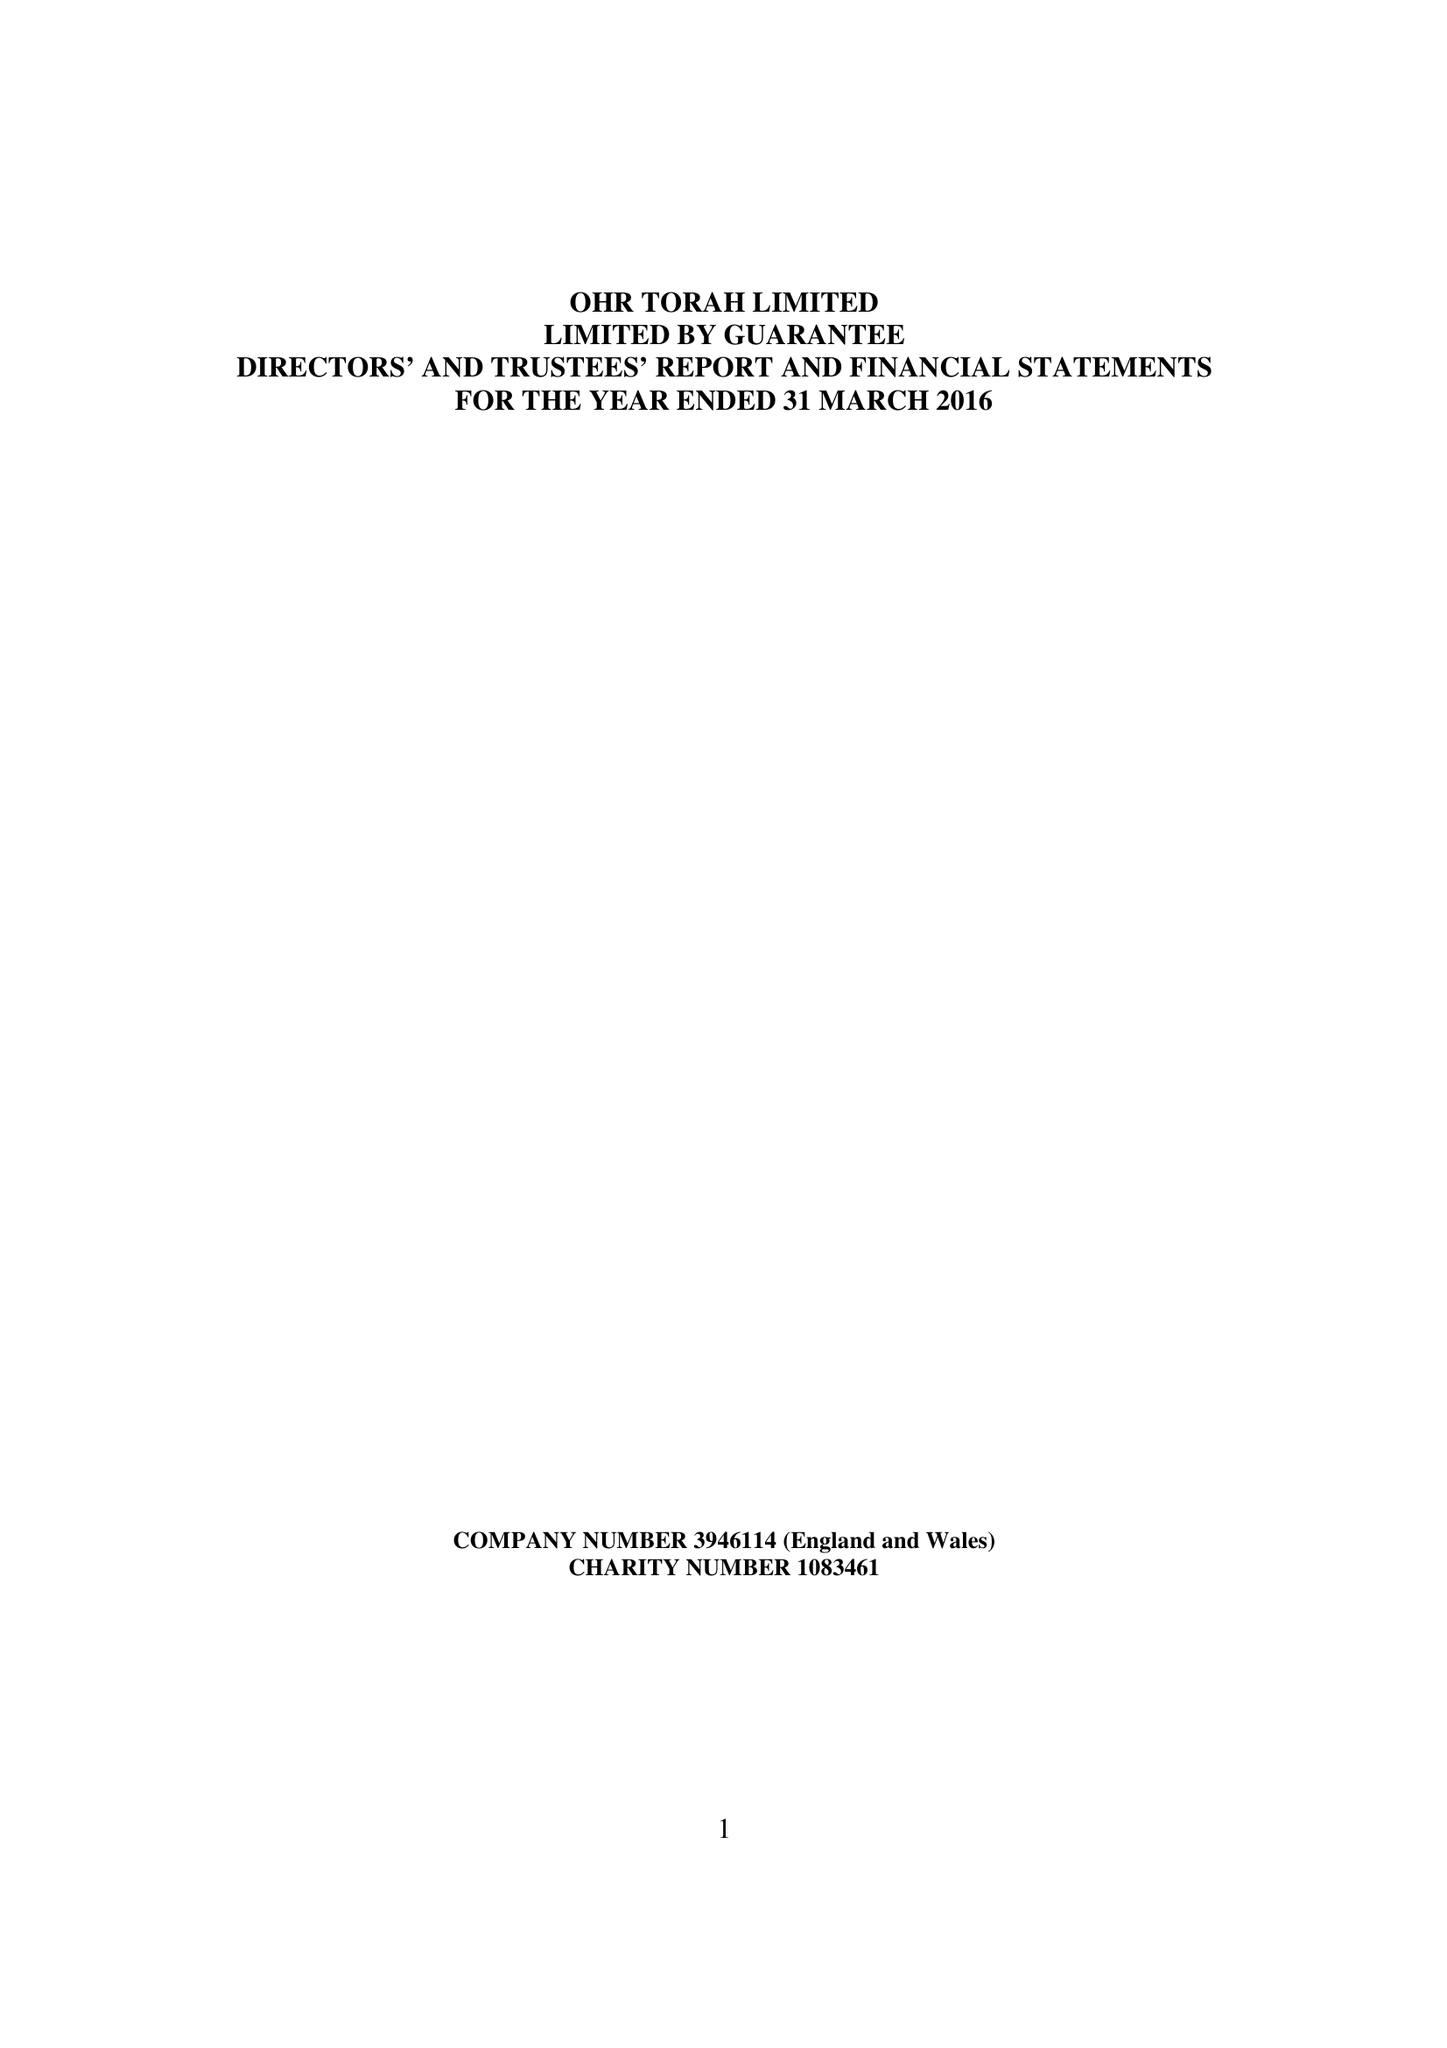What is the value for the report_date?
Answer the question using a single word or phrase. 2016-03-31 